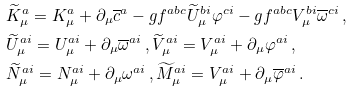Convert formula to latex. <formula><loc_0><loc_0><loc_500><loc_500>& \widetilde { K } _ { \mu } ^ { a } = K _ { \mu } ^ { a } + \partial _ { \mu } \overline { c } ^ { a } - g f ^ { a b c } \widetilde { U } _ { \mu } ^ { b i } \varphi ^ { c i } - g f ^ { a b c } V _ { \mu } ^ { b i } \overline { \omega } ^ { c i } \, , \\ & \widetilde { U } _ { \mu } ^ { a i } = U _ { \mu } ^ { a i } + \partial _ { \mu } \overline { \omega } ^ { a i } \, , \widetilde { V } _ { \mu } ^ { a i } = V _ { \mu } ^ { a i } + \partial _ { \mu } \varphi ^ { a i } \, , \\ & \widetilde { N } _ { \mu } ^ { a i } = N _ { \mu } ^ { a i } + \partial _ { \mu } \omega ^ { a i } \, , \widetilde { M } _ { \mu } ^ { a i } = V _ { \mu } ^ { a i } + \partial _ { \mu } \overline { \varphi } ^ { a i } \, .</formula> 